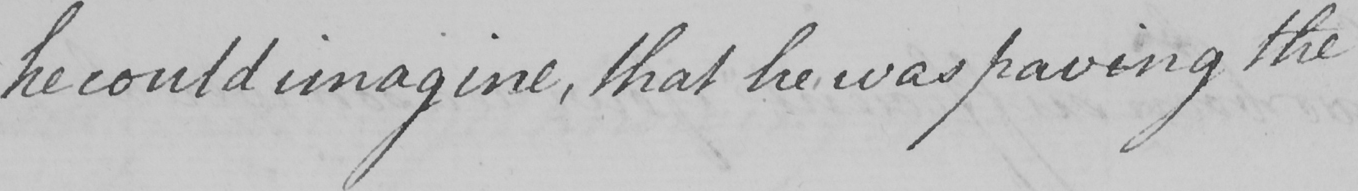Please transcribe the handwritten text in this image. he could imagine , that he was paving the 